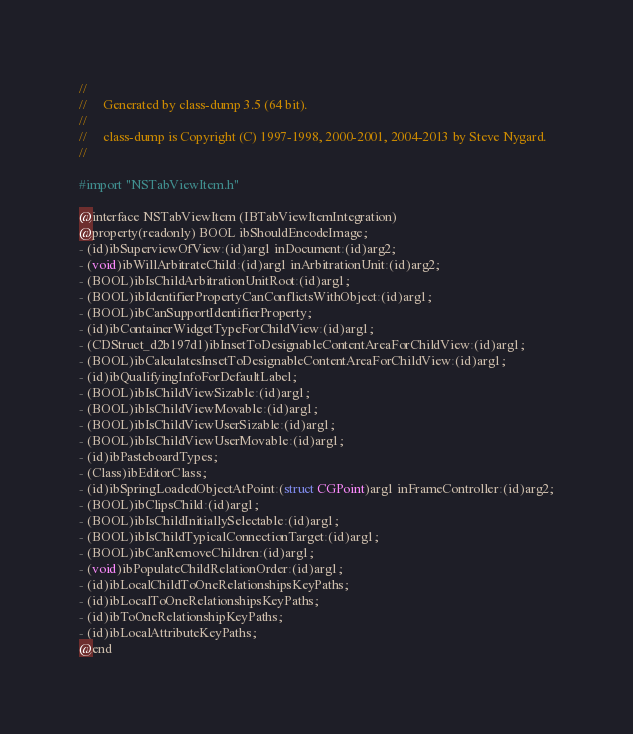Convert code to text. <code><loc_0><loc_0><loc_500><loc_500><_C_>//
//     Generated by class-dump 3.5 (64 bit).
//
//     class-dump is Copyright (C) 1997-1998, 2000-2001, 2004-2013 by Steve Nygard.
//

#import "NSTabViewItem.h"

@interface NSTabViewItem (IBTabViewItemIntegration)
@property(readonly) BOOL ibShouldEncodeImage;
- (id)ibSuperviewOfView:(id)arg1 inDocument:(id)arg2;
- (void)ibWillArbitrateChild:(id)arg1 inArbitrationUnit:(id)arg2;
- (BOOL)ibIsChildArbitrationUnitRoot:(id)arg1;
- (BOOL)ibIdentifierPropertyCanConflictsWithObject:(id)arg1;
- (BOOL)ibCanSupportIdentifierProperty;
- (id)ibContainerWidgetTypeForChildView:(id)arg1;
- (CDStruct_d2b197d1)ibInsetToDesignableContentAreaForChildView:(id)arg1;
- (BOOL)ibCalculatesInsetToDesignableContentAreaForChildView:(id)arg1;
- (id)ibQualifyingInfoForDefaultLabel;
- (BOOL)ibIsChildViewSizable:(id)arg1;
- (BOOL)ibIsChildViewMovable:(id)arg1;
- (BOOL)ibIsChildViewUserSizable:(id)arg1;
- (BOOL)ibIsChildViewUserMovable:(id)arg1;
- (id)ibPasteboardTypes;
- (Class)ibEditorClass;
- (id)ibSpringLoadedObjectAtPoint:(struct CGPoint)arg1 inFrameController:(id)arg2;
- (BOOL)ibClipsChild:(id)arg1;
- (BOOL)ibIsChildInitiallySelectable:(id)arg1;
- (BOOL)ibIsChildTypicalConnectionTarget:(id)arg1;
- (BOOL)ibCanRemoveChildren:(id)arg1;
- (void)ibPopulateChildRelationOrder:(id)arg1;
- (id)ibLocalChildToOneRelationshipsKeyPaths;
- (id)ibLocalToOneRelationshipsKeyPaths;
- (id)ibToOneRelationshipKeyPaths;
- (id)ibLocalAttributeKeyPaths;
@end

</code> 